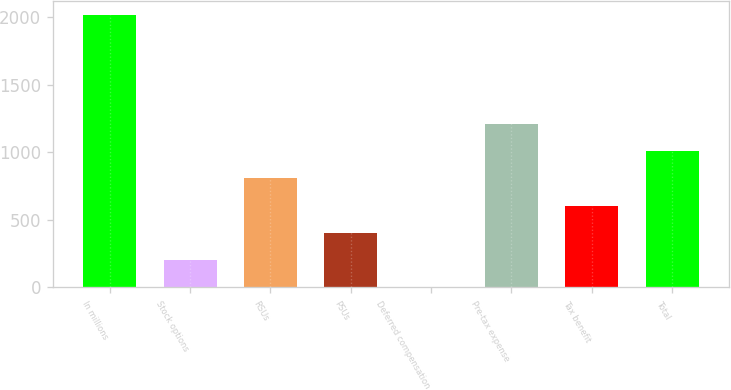Convert chart. <chart><loc_0><loc_0><loc_500><loc_500><bar_chart><fcel>In millions<fcel>Stock options<fcel>RSUs<fcel>PSUs<fcel>Deferred compensation<fcel>Pre-tax expense<fcel>Tax benefit<fcel>Total<nl><fcel>2014<fcel>202.12<fcel>806.08<fcel>403.44<fcel>0.8<fcel>1208.72<fcel>604.76<fcel>1007.4<nl></chart> 